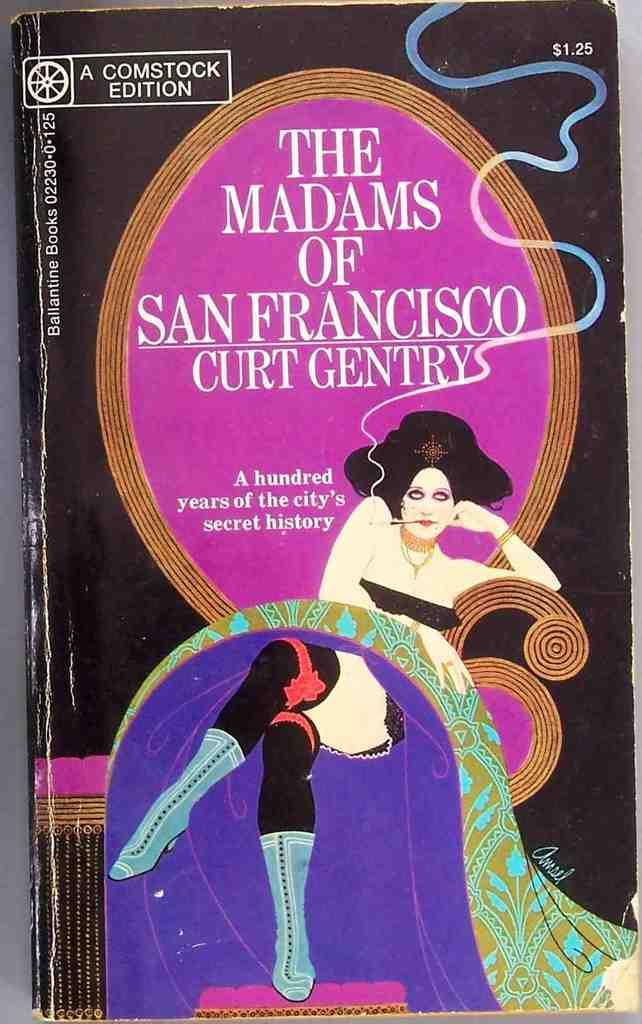What is depicted in the painting in the image? There is a painting of a woman in the image. What else can be seen in the painting besides the woman? There is text written with the paint in the image. What type of cub can be seen playing with the brass in the image? There is no cub or brass present in the image; it only features a painting of a woman with text written with the paint. 